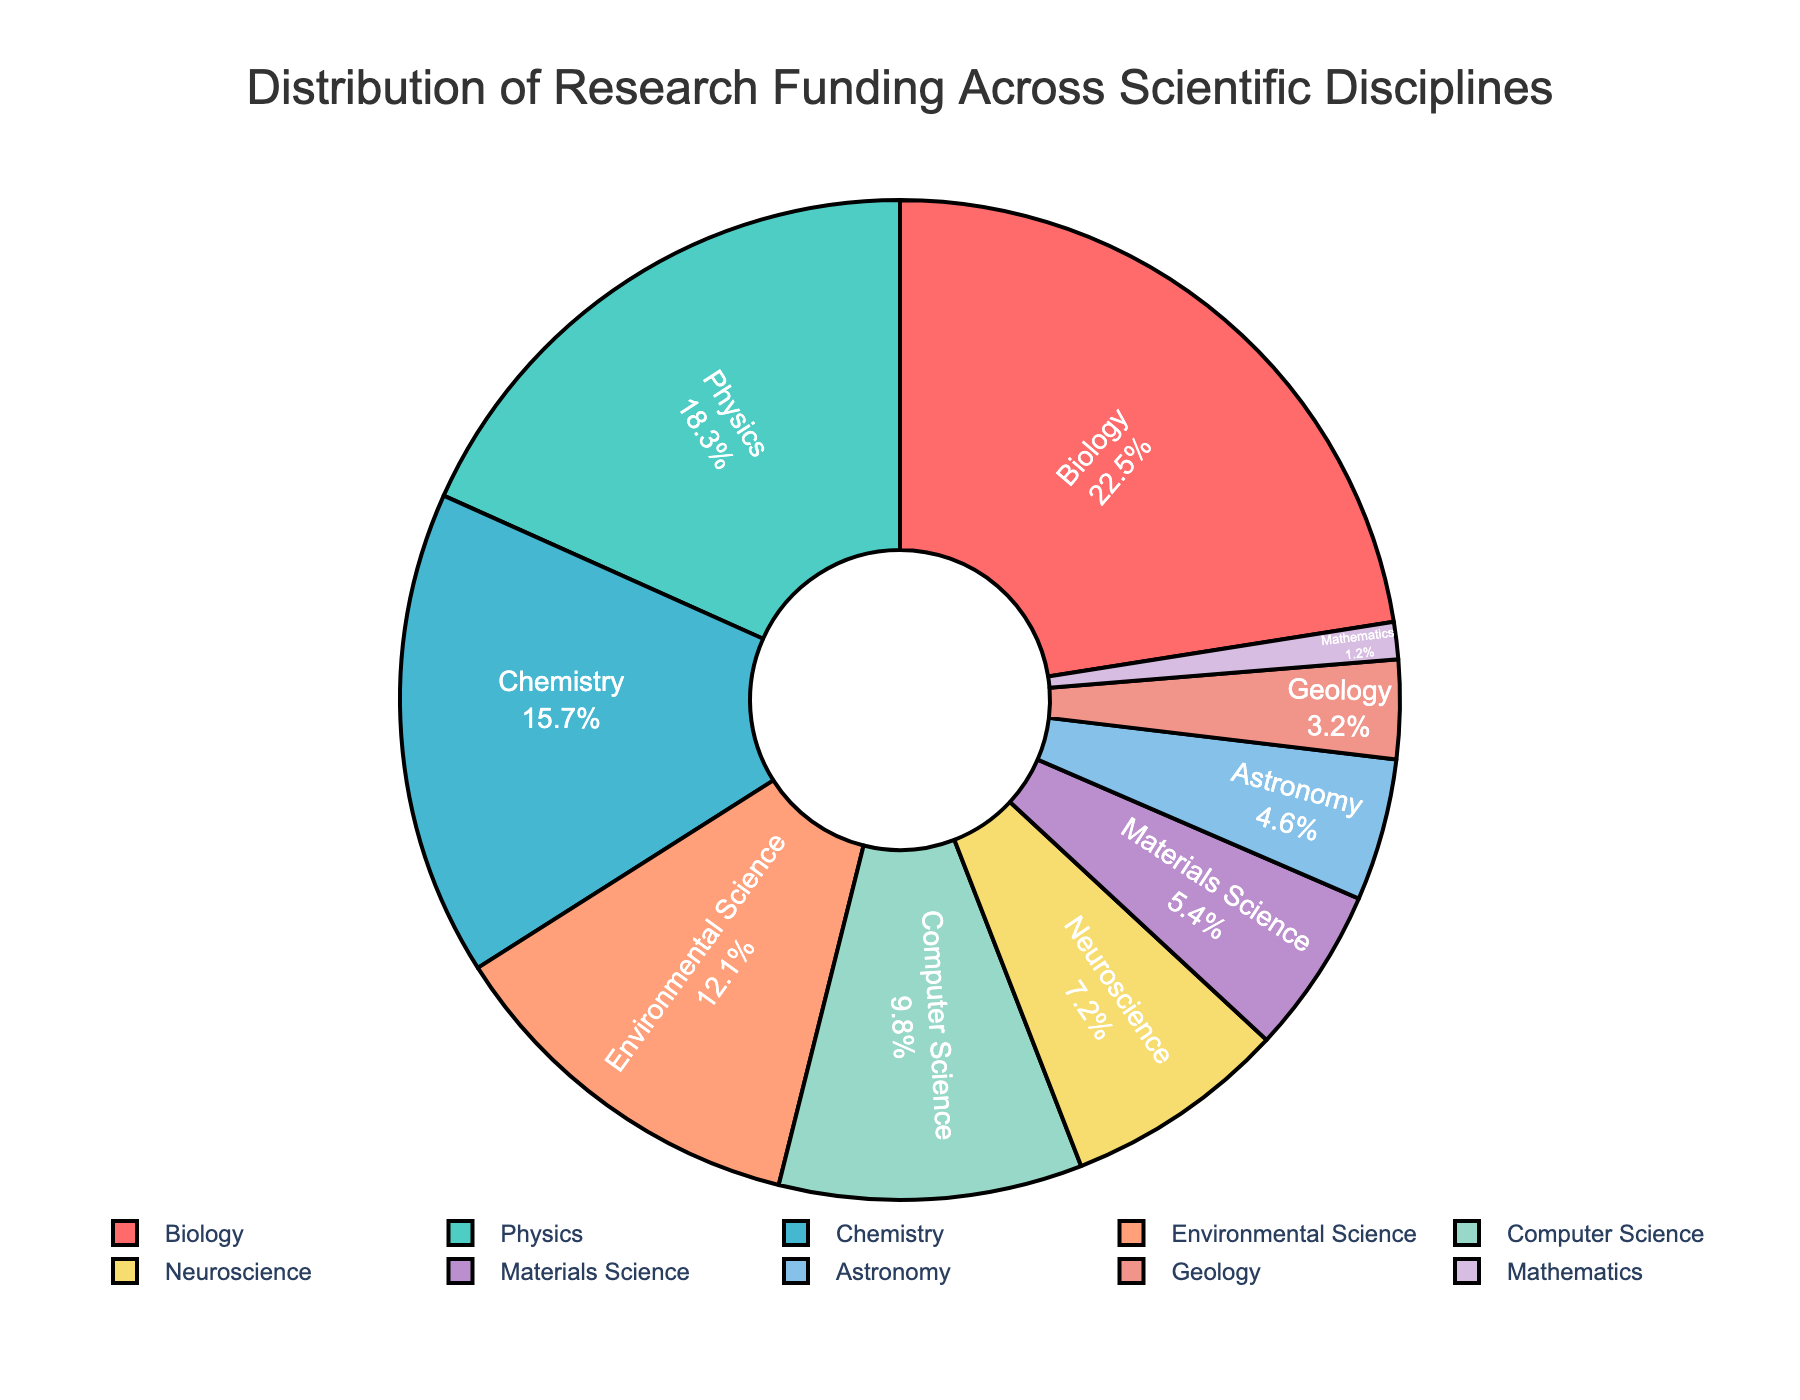What's the total funding percentage for Chemistry and Physics? Sum the funding percentages for Chemistry (15.7%) and Physics (18.3%). 15.7 + 18.3 = 34.0
Answer: 34.0 Which discipline has the smallest funding percentage? Identify the discipline with the smallest slice in the pie chart. Mathematics has the smallest slice with 1.2%.
Answer: Mathematics What percentage of research funding is allocated to Biology compared to Computer Science? Check the pie chart. Biology is 22.5%, and Computer Science is 9.8%. Bio is larger by 22.5% - 9.8% = 12.7%.
Answer: 12.7 Which disciplines have a funding percentage less than 10%? Identify slices in the pie chart with funding under 10%. Computer Science (9.8%), Neuroscience (7.2%), Materials Science (5.4%), Astronomy (4.6%), Geology (3.2%), Mathematics (1.2%).
Answer: Computer Science, Neuroscience, Materials Science, Astronomy, Geology, Mathematics What is the combined funding percentage for the top three disciplines? Sum the funding percentages for the three largest slices: Biology (22.5%), Physics (18.3%), and Chemistry (15.7%). 22.5 + 18.3 + 15.7 = 56.5
Answer: 56.5 Which discipline has nearly double the funding percentage of Geology? Find the discipline with a funding percentage close to 2 * 3.2%. Environmental Science is near at 12.1%.
Answer: Environmental Science Which color represents Neuroscience in the pie chart and what is its funding percentage? Neurological slice is 7.2% and should be light yellow (6th slice). Check the similar slice in the color legend.
Answer: Light yellow, 7.2 Is there a discipline funded between 10% to 15%? Check the pie chart for slices within this range. Environmental Science falls here with 12.1%.
Answer: Environmental Science 